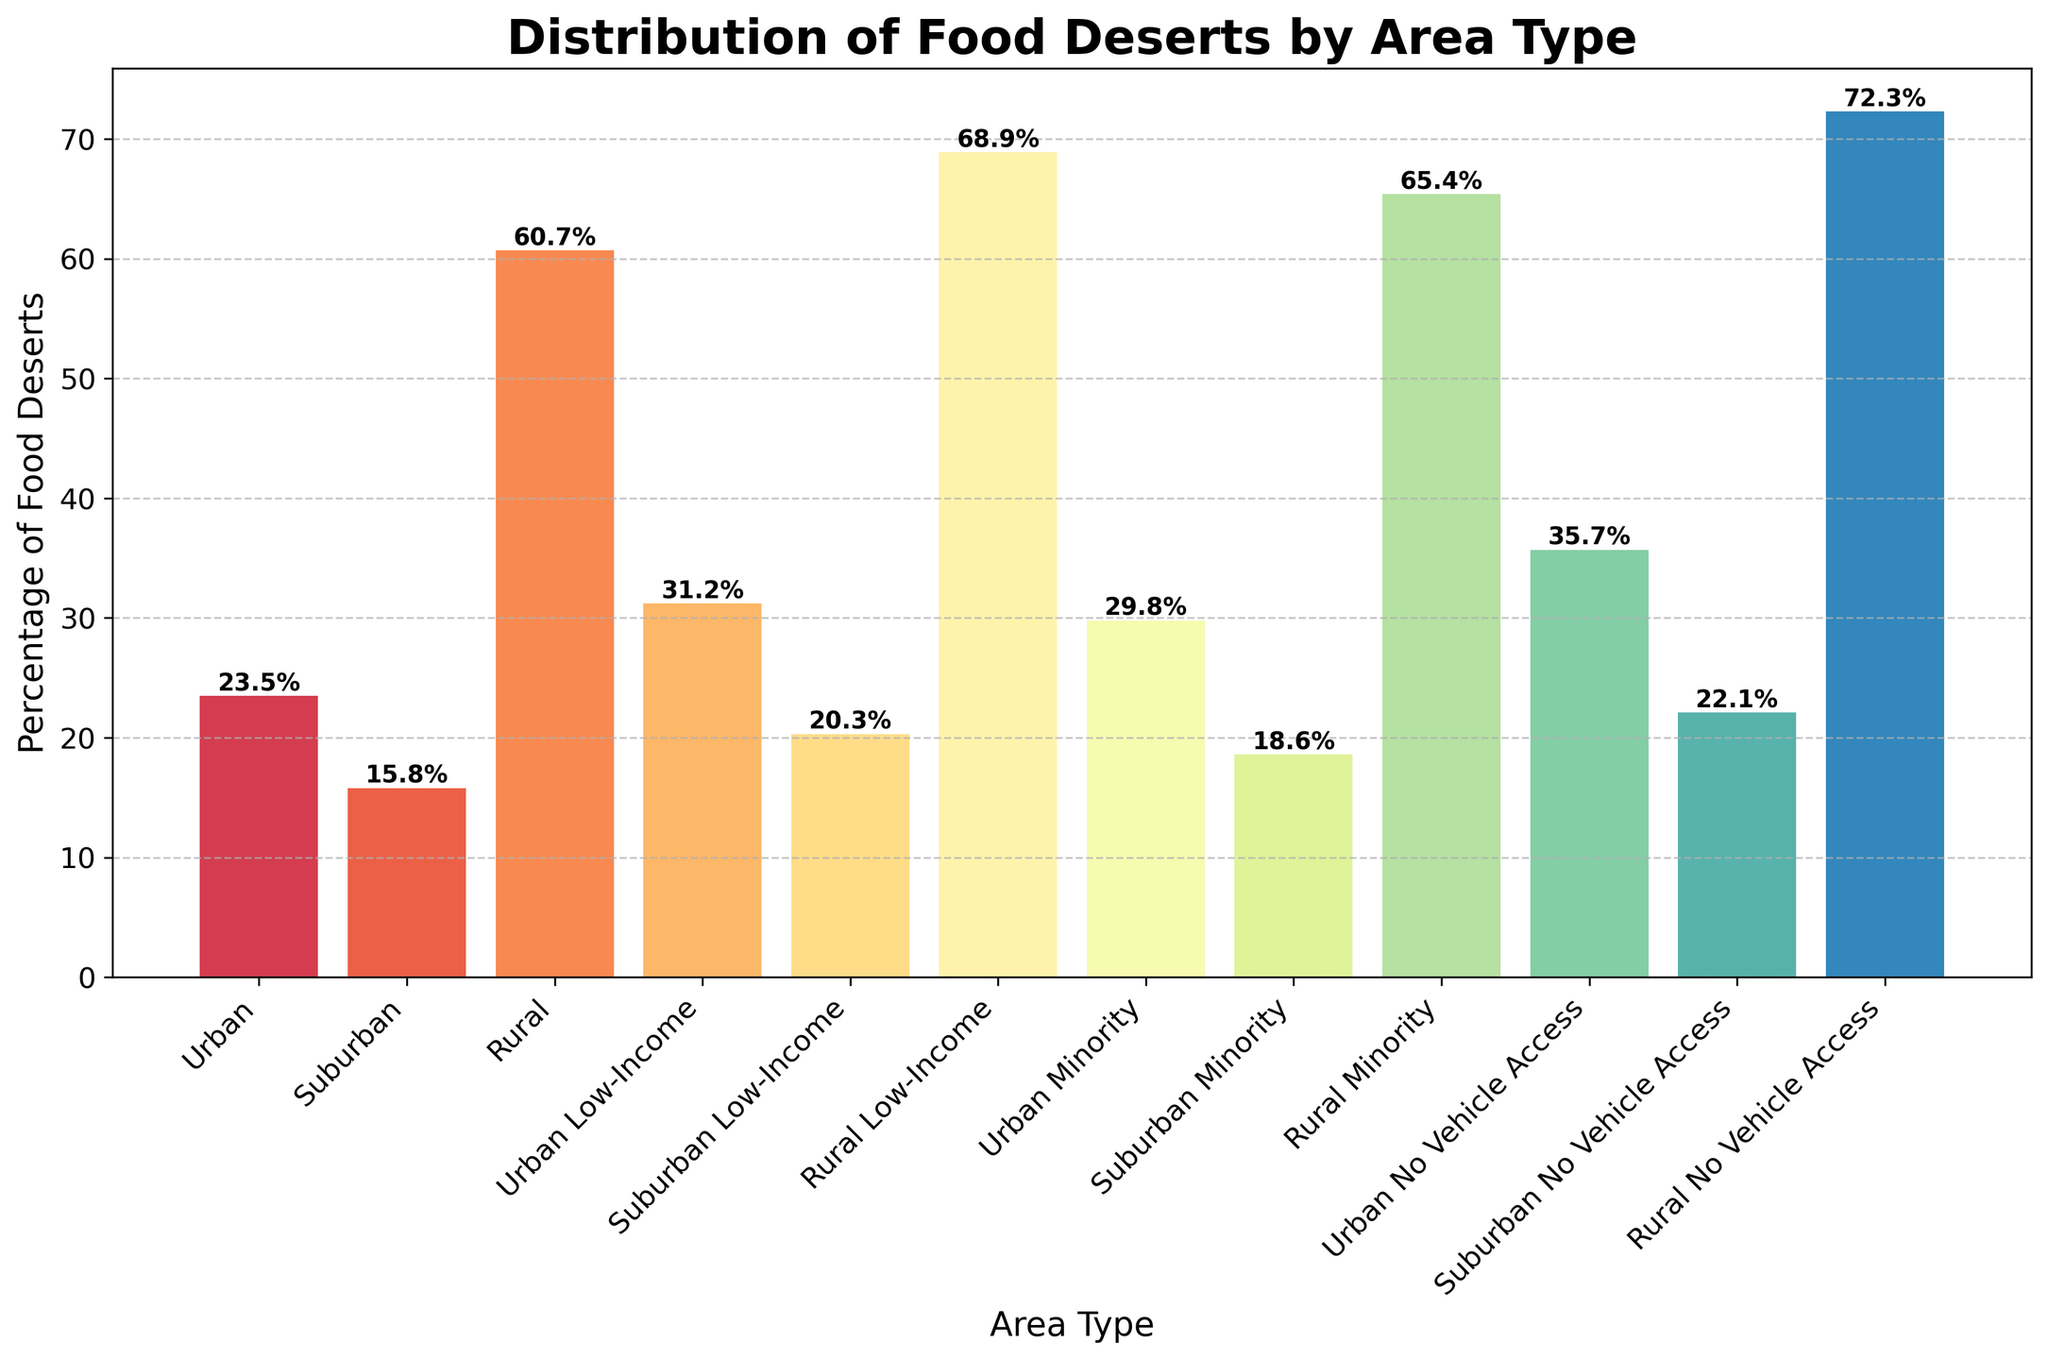What area type has the highest percentage of food deserts? By looking at the height of the bars in the chart, the highest bar represents Rural No Vehicle Access with a percentage of 72.3%.
Answer: Rural No Vehicle Access Which area type has the lowest percentage of food deserts? The lowest bar in the chart represents Suburban with a percentage of 15.8%.
Answer: Suburban What is the difference in the percentage of food deserts between Urban and Urban Low-Income areas? The percentage for Urban is 23.5% and for Urban Low-Income is 31.2%. The difference is calculated as 31.2 - 23.5 = 7.7%.
Answer: 7.7% How do the food desert percentages for Rural Low-Income and Urban No Vehicle Access compare? The percentage for Rural Low-Income is 68.9%, and for Urban No Vehicle Access is 35.7%. Therefore, Rural Low-Income is higher.
Answer: Rural Low-Income is higher Which area type shows a greater percentage of food deserts: Suburban Minority or Rural? The percentage for Suburban Minority is 18.6%, and for Rural is 60.7%. Therefore, Rural is greater.
Answer: Rural is greater What is the average percentage of food deserts across all Urban area types listed? The percentages for Urban area types are 23.5%, 31.2%, 29.8%, and 35.7%. Adding these gives 120.2, and dividing by 4 gives 120.2 / 4 = 30.05%.
Answer: 30.05% Which has the higher percentage of food deserts: Urban Minority or Suburban No Vehicle Access? The percentage for Urban Minority is 29.8%, and for Suburban No Vehicle Access is 22.1%. Therefore, Urban Minority is higher.
Answer: Urban Minority is higher How does the percentage of food deserts in Urban compare to Suburban? The percentage for Urban is 23.5% and for Suburban is 15.8%. Therefore, Urban is higher.
Answer: Urban is higher What is the sum of the percentages of food deserts for Suburban Low-Income and Rural areas? The percentage for Suburban Low-Income is 20.3% and for Rural is 60.7%. Their sum is 20.3 + 60.7 = 81%.
Answer: 81% 